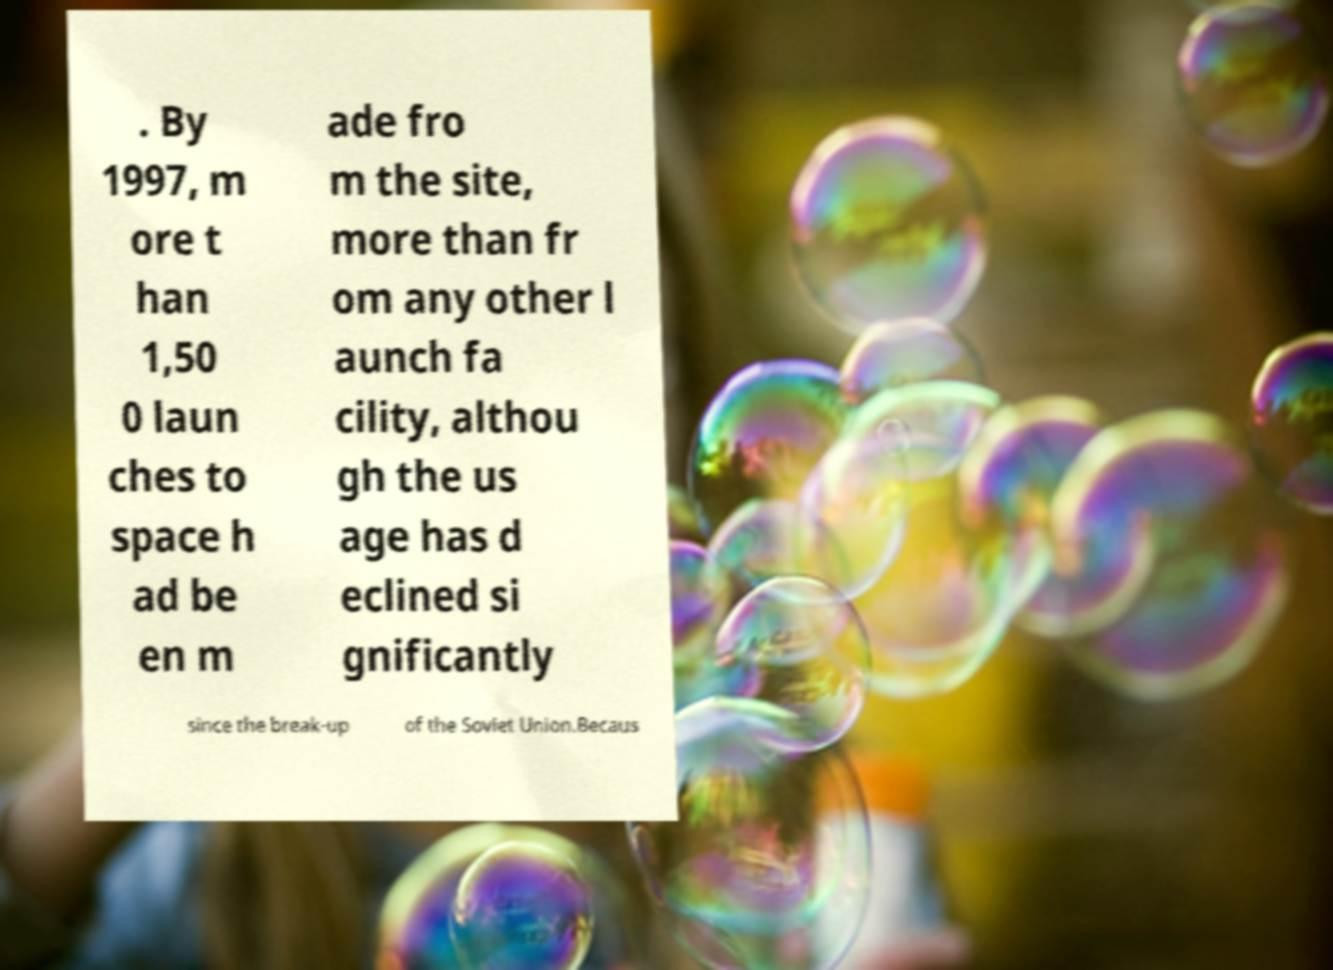Could you extract and type out the text from this image? . By 1997, m ore t han 1,50 0 laun ches to space h ad be en m ade fro m the site, more than fr om any other l aunch fa cility, althou gh the us age has d eclined si gnificantly since the break-up of the Soviet Union.Becaus 